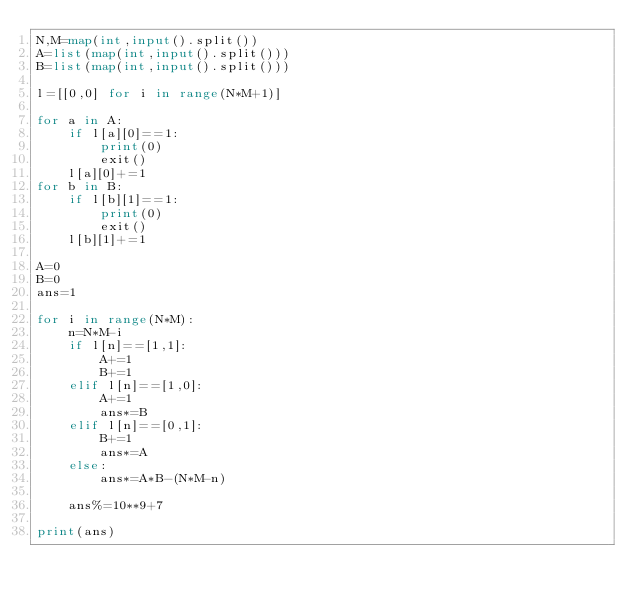<code> <loc_0><loc_0><loc_500><loc_500><_Python_>N,M=map(int,input().split())
A=list(map(int,input().split()))
B=list(map(int,input().split()))

l=[[0,0] for i in range(N*M+1)]

for a in A:
    if l[a][0]==1:
        print(0)
        exit()
    l[a][0]+=1
for b in B:
    if l[b][1]==1:
        print(0)
        exit()
    l[b][1]+=1

A=0
B=0
ans=1

for i in range(N*M):
    n=N*M-i
    if l[n]==[1,1]:
        A+=1
        B+=1
    elif l[n]==[1,0]:
        A+=1
        ans*=B
    elif l[n]==[0,1]:
        B+=1
        ans*=A
    else:
        ans*=A*B-(N*M-n)

    ans%=10**9+7

print(ans)
</code> 